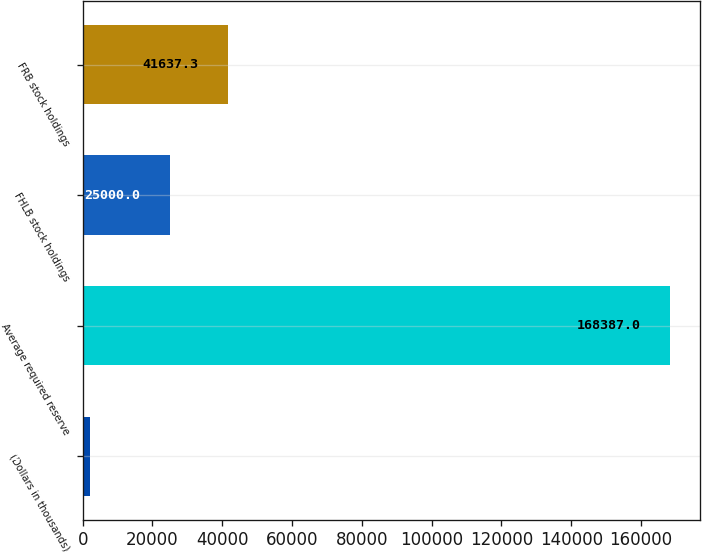Convert chart to OTSL. <chart><loc_0><loc_0><loc_500><loc_500><bar_chart><fcel>(Dollars in thousands)<fcel>Average required reserve<fcel>FHLB stock holdings<fcel>FRB stock holdings<nl><fcel>2014<fcel>168387<fcel>25000<fcel>41637.3<nl></chart> 